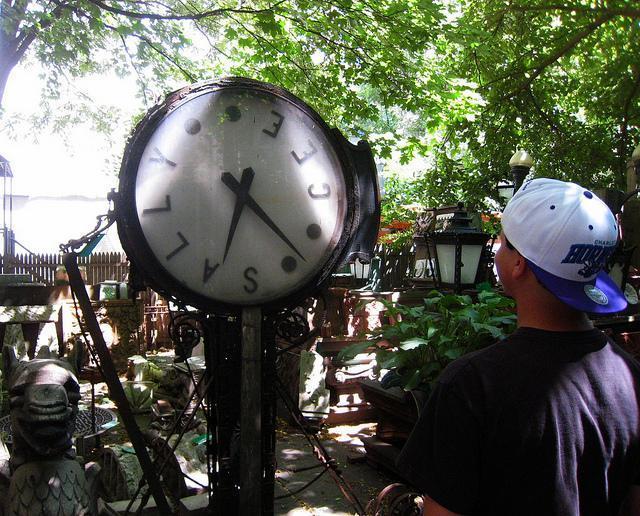How many zebras can you see?
Give a very brief answer. 0. 